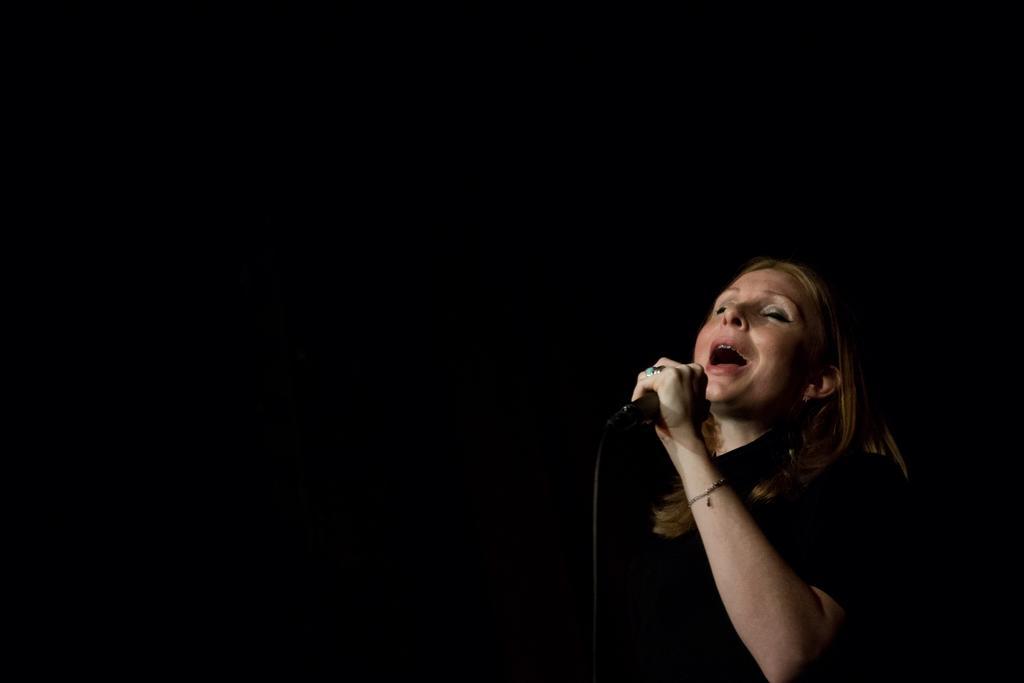Could you give a brief overview of what you see in this image? On the right side of the picture there is a woman holding a mic and singing. The background is dark. 